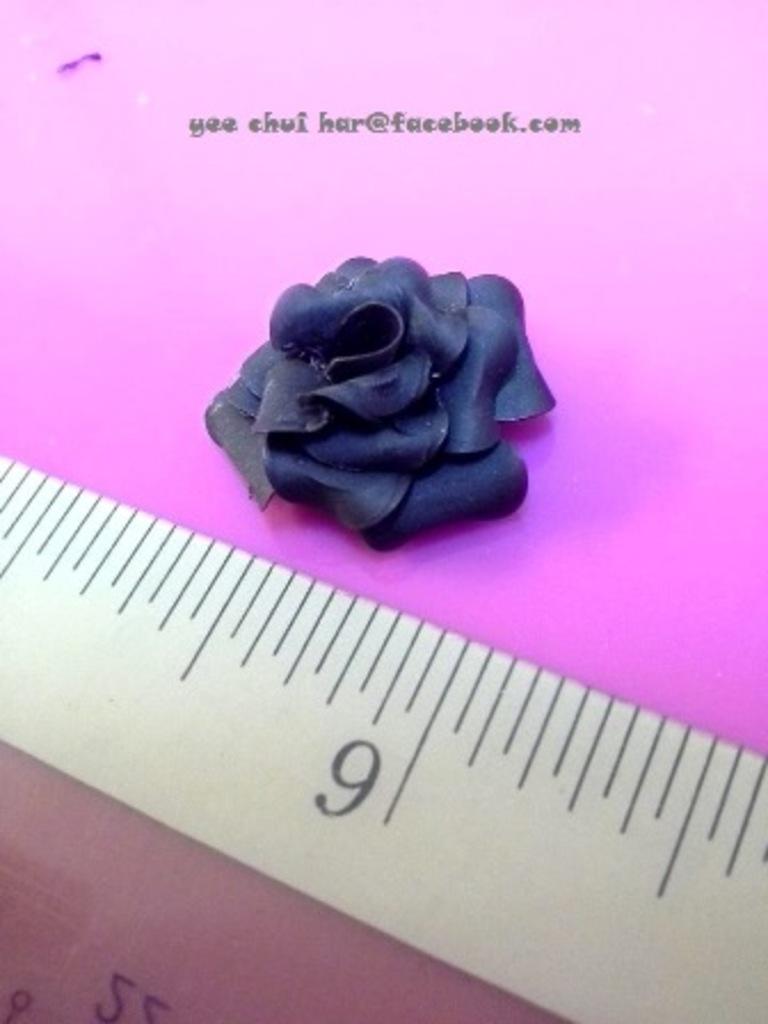What increment is written on the ruler?
Offer a very short reply. 9. 